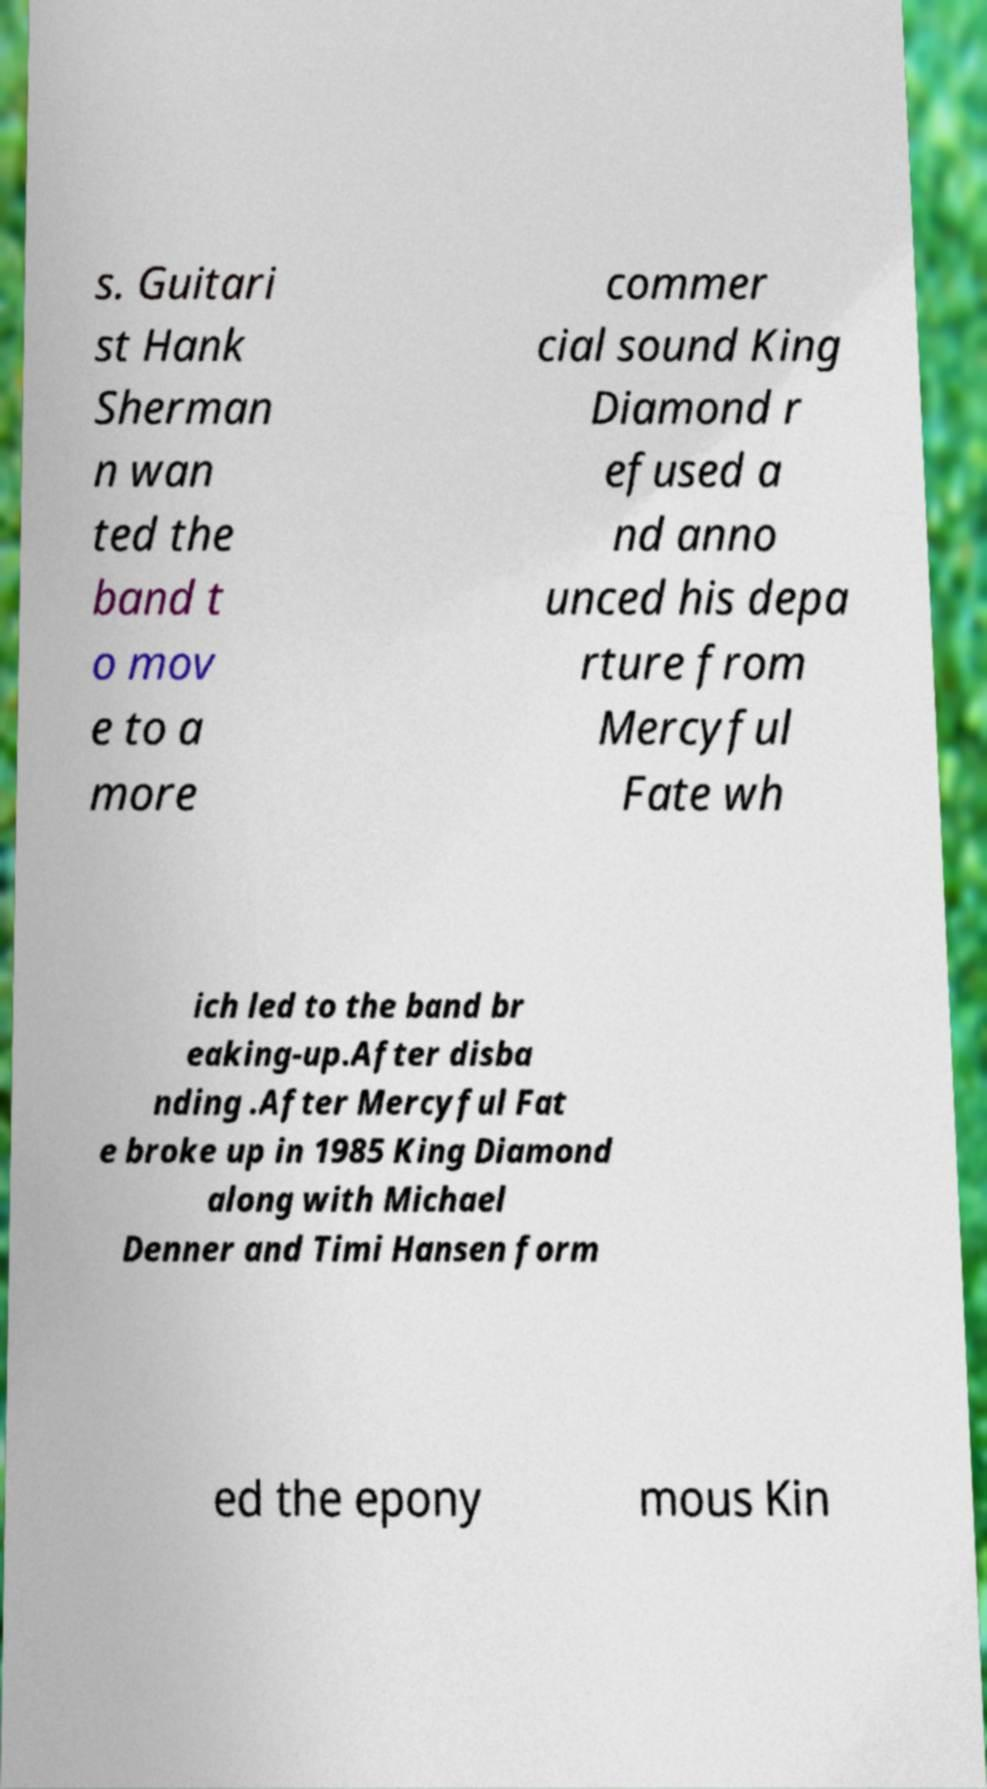Could you assist in decoding the text presented in this image and type it out clearly? s. Guitari st Hank Sherman n wan ted the band t o mov e to a more commer cial sound King Diamond r efused a nd anno unced his depa rture from Mercyful Fate wh ich led to the band br eaking-up.After disba nding .After Mercyful Fat e broke up in 1985 King Diamond along with Michael Denner and Timi Hansen form ed the epony mous Kin 